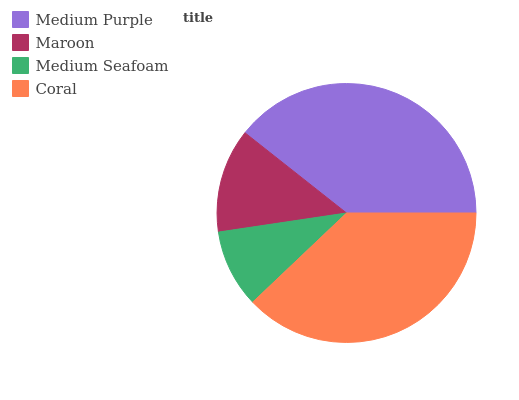Is Medium Seafoam the minimum?
Answer yes or no. Yes. Is Medium Purple the maximum?
Answer yes or no. Yes. Is Maroon the minimum?
Answer yes or no. No. Is Maroon the maximum?
Answer yes or no. No. Is Medium Purple greater than Maroon?
Answer yes or no. Yes. Is Maroon less than Medium Purple?
Answer yes or no. Yes. Is Maroon greater than Medium Purple?
Answer yes or no. No. Is Medium Purple less than Maroon?
Answer yes or no. No. Is Coral the high median?
Answer yes or no. Yes. Is Maroon the low median?
Answer yes or no. Yes. Is Medium Seafoam the high median?
Answer yes or no. No. Is Coral the low median?
Answer yes or no. No. 